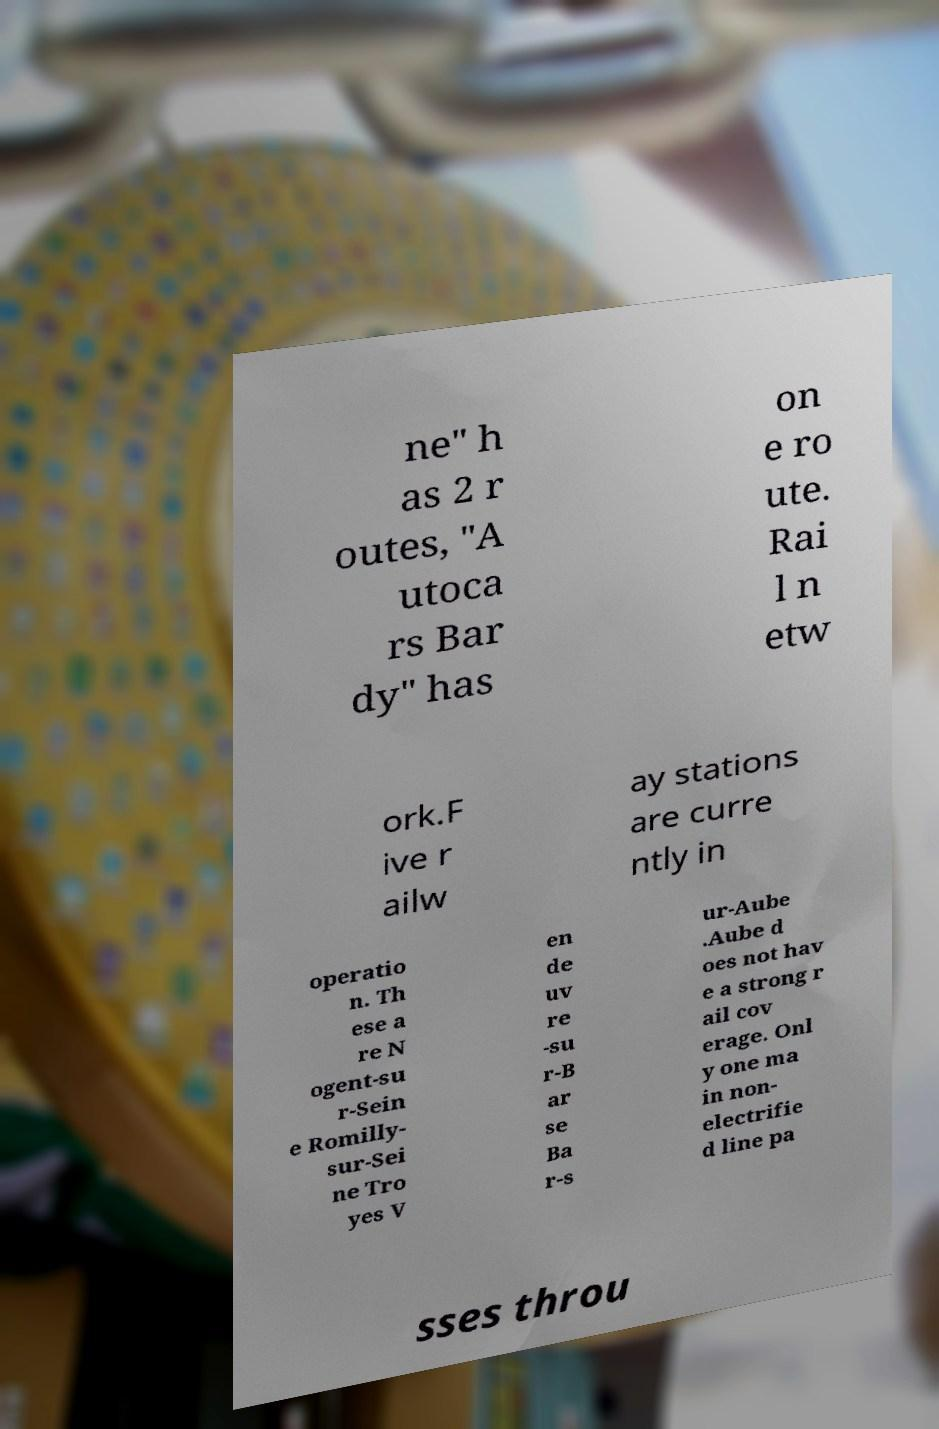What messages or text are displayed in this image? I need them in a readable, typed format. ne" h as 2 r outes, "A utoca rs Bar dy" has on e ro ute. Rai l n etw ork.F ive r ailw ay stations are curre ntly in operatio n. Th ese a re N ogent-su r-Sein e Romilly- sur-Sei ne Tro yes V en de uv re -su r-B ar se Ba r-s ur-Aube .Aube d oes not hav e a strong r ail cov erage. Onl y one ma in non- electrifie d line pa sses throu 